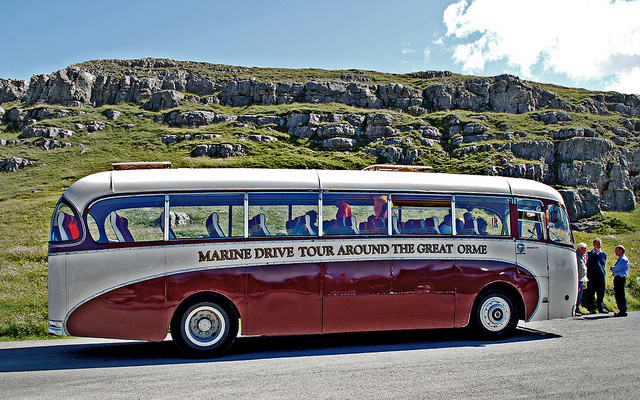Please identify all text content in this image. MARINE DRIVE TOUR. AROUNG THE ORME GREAT 